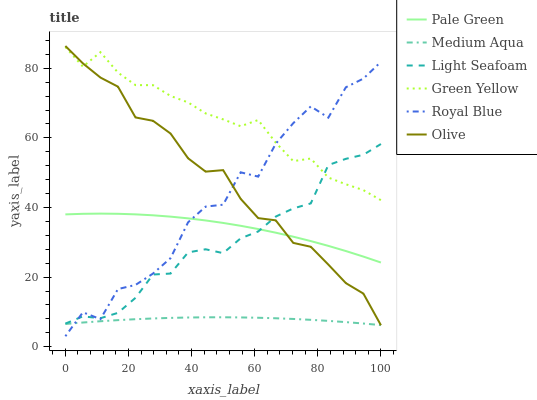Does Medium Aqua have the minimum area under the curve?
Answer yes or no. Yes. Does Green Yellow have the maximum area under the curve?
Answer yes or no. Yes. Does Royal Blue have the minimum area under the curve?
Answer yes or no. No. Does Royal Blue have the maximum area under the curve?
Answer yes or no. No. Is Medium Aqua the smoothest?
Answer yes or no. Yes. Is Royal Blue the roughest?
Answer yes or no. Yes. Is Pale Green the smoothest?
Answer yes or no. No. Is Pale Green the roughest?
Answer yes or no. No. Does Royal Blue have the lowest value?
Answer yes or no. Yes. Does Pale Green have the lowest value?
Answer yes or no. No. Does Olive have the highest value?
Answer yes or no. Yes. Does Royal Blue have the highest value?
Answer yes or no. No. Is Medium Aqua less than Light Seafoam?
Answer yes or no. Yes. Is Light Seafoam greater than Medium Aqua?
Answer yes or no. Yes. Does Green Yellow intersect Royal Blue?
Answer yes or no. Yes. Is Green Yellow less than Royal Blue?
Answer yes or no. No. Is Green Yellow greater than Royal Blue?
Answer yes or no. No. Does Medium Aqua intersect Light Seafoam?
Answer yes or no. No. 